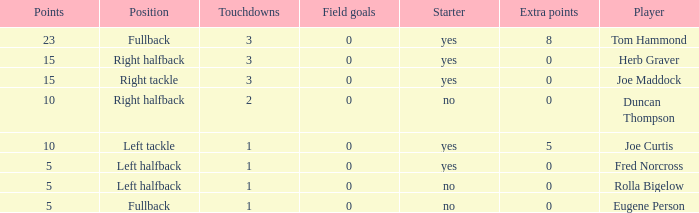What is the average number of field goals scored by a right halfback who had more than 3 touchdowns? None. Could you help me parse every detail presented in this table? {'header': ['Points', 'Position', 'Touchdowns', 'Field goals', 'Starter', 'Extra points', 'Player'], 'rows': [['23', 'Fullback', '3', '0', 'yes', '8', 'Tom Hammond'], ['15', 'Right halfback', '3', '0', 'yes', '0', 'Herb Graver'], ['15', 'Right tackle', '3', '0', 'yes', '0', 'Joe Maddock'], ['10', 'Right halfback', '2', '0', 'no', '0', 'Duncan Thompson'], ['10', 'Left tackle', '1', '0', 'yes', '5', 'Joe Curtis'], ['5', 'Left halfback', '1', '0', 'yes', '0', 'Fred Norcross'], ['5', 'Left halfback', '1', '0', 'no', '0', 'Rolla Bigelow'], ['5', 'Fullback', '1', '0', 'no', '0', 'Eugene Person']]} 